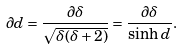Convert formula to latex. <formula><loc_0><loc_0><loc_500><loc_500>\partial d = \frac { \partial \delta } { \sqrt { \delta ( \delta + 2 ) } } = \frac { \partial \delta } { \sinh d } .</formula> 